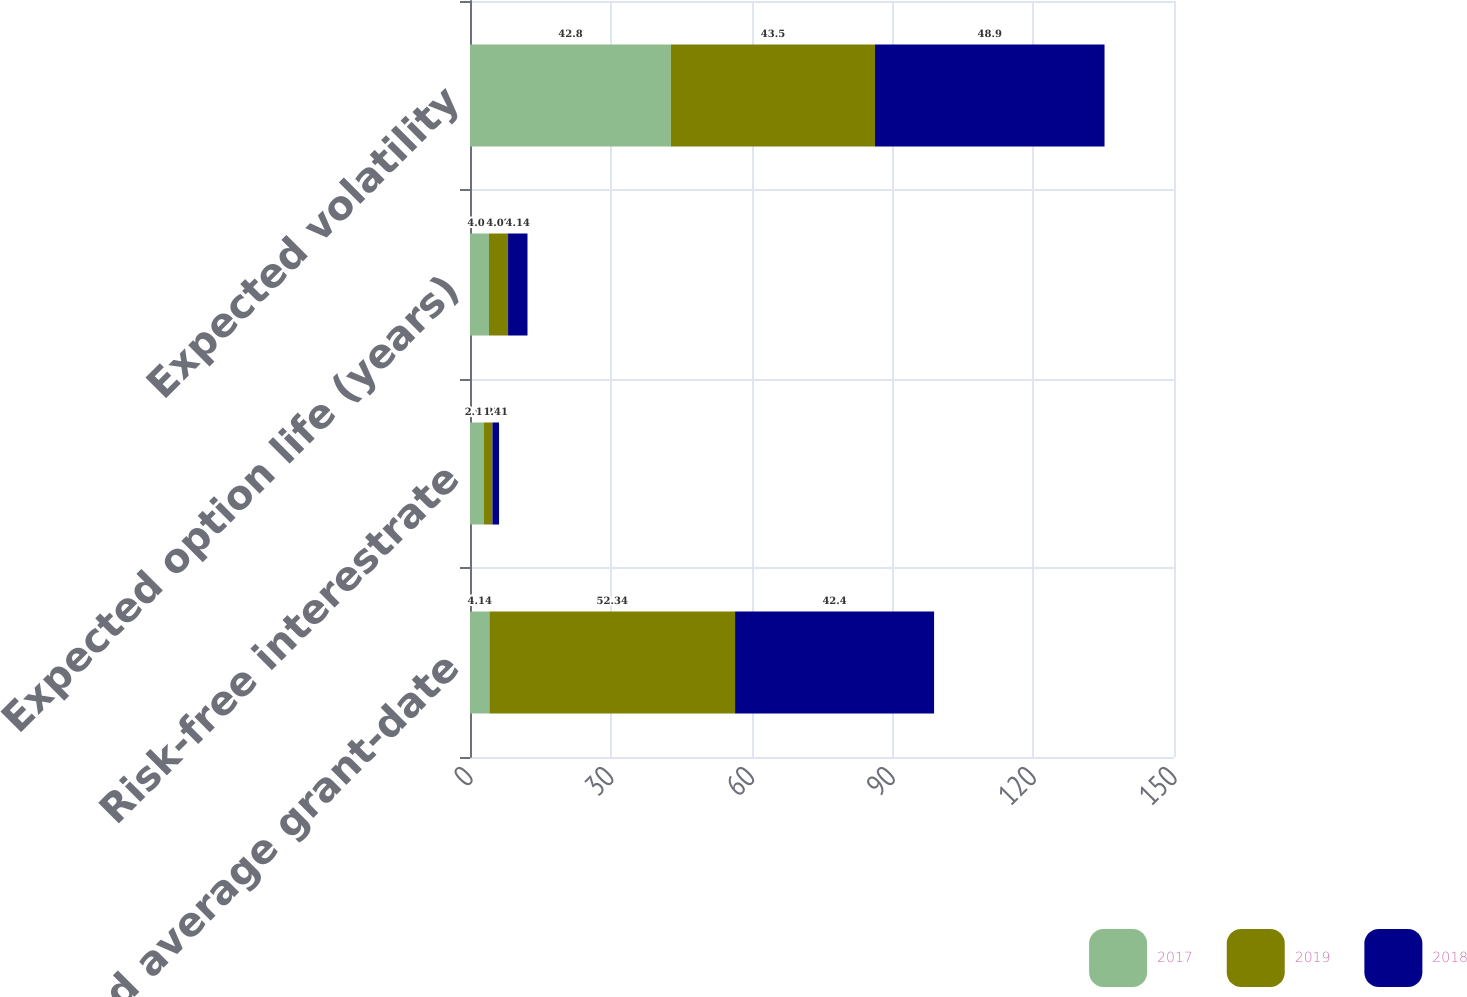Convert chart to OTSL. <chart><loc_0><loc_0><loc_500><loc_500><stacked_bar_chart><ecel><fcel>Weighted average grant-date<fcel>Risk-free interestrate<fcel>Expected option life (years)<fcel>Expected volatility<nl><fcel>2017<fcel>4.14<fcel>2.91<fcel>4.04<fcel>42.8<nl><fcel>2019<fcel>52.34<fcel>1.87<fcel>4.07<fcel>43.5<nl><fcel>2018<fcel>42.4<fcel>1.41<fcel>4.14<fcel>48.9<nl></chart> 